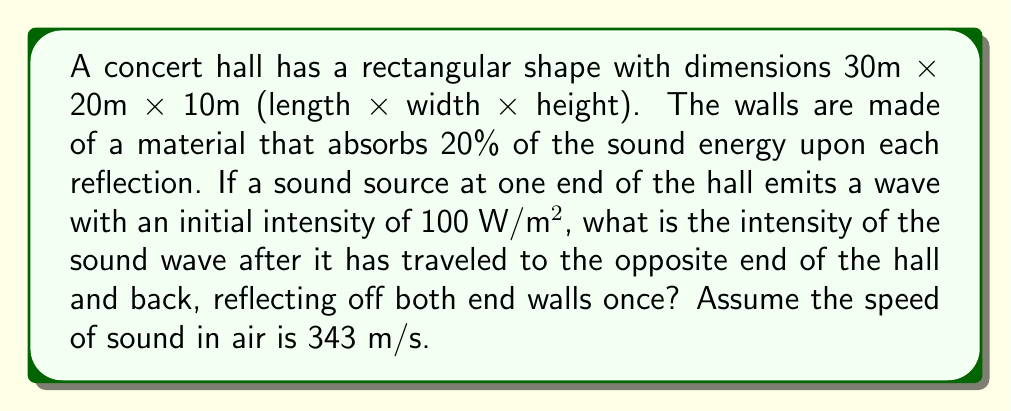Give your solution to this math problem. Let's approach this step-by-step:

1) First, we need to calculate the total distance the sound wave travels:
   $$d = 2 \times 30\text{ m} = 60\text{ m}$$

2) The intensity of a sound wave decreases with distance according to the inverse square law:
   $$I = \frac{I_0}{4\pi r^2}$$
   where $I_0$ is the initial intensity and $r$ is the distance from the source.

3) At the opposite end of the hall (30 m), the intensity would be:
   $$I_{30} = \frac{100}{4\pi (30)^2} = 0.0884\text{ W/m²}$$

4) This wave then reflects off the wall, losing 20% of its energy:
   $$I_{reflected} = 0.0884 \times 0.8 = 0.0707\text{ W/m²}$$

5) The reflected wave then travels back to the original end, again decreasing according to the inverse square law:
   $$I_{final} = \frac{0.0707}{4\pi (30)^2} = 6.26 \times 10^{-5}\text{ W/m²}$$

6) This wave reflects off the original wall, again losing 20% of its energy:
   $$I_{final\_reflected} = 6.26 \times 10^{-5} \times 0.8 = 5.01 \times 10^{-5}\text{ W/m²}$$
Answer: $5.01 \times 10^{-5}\text{ W/m²}$ 